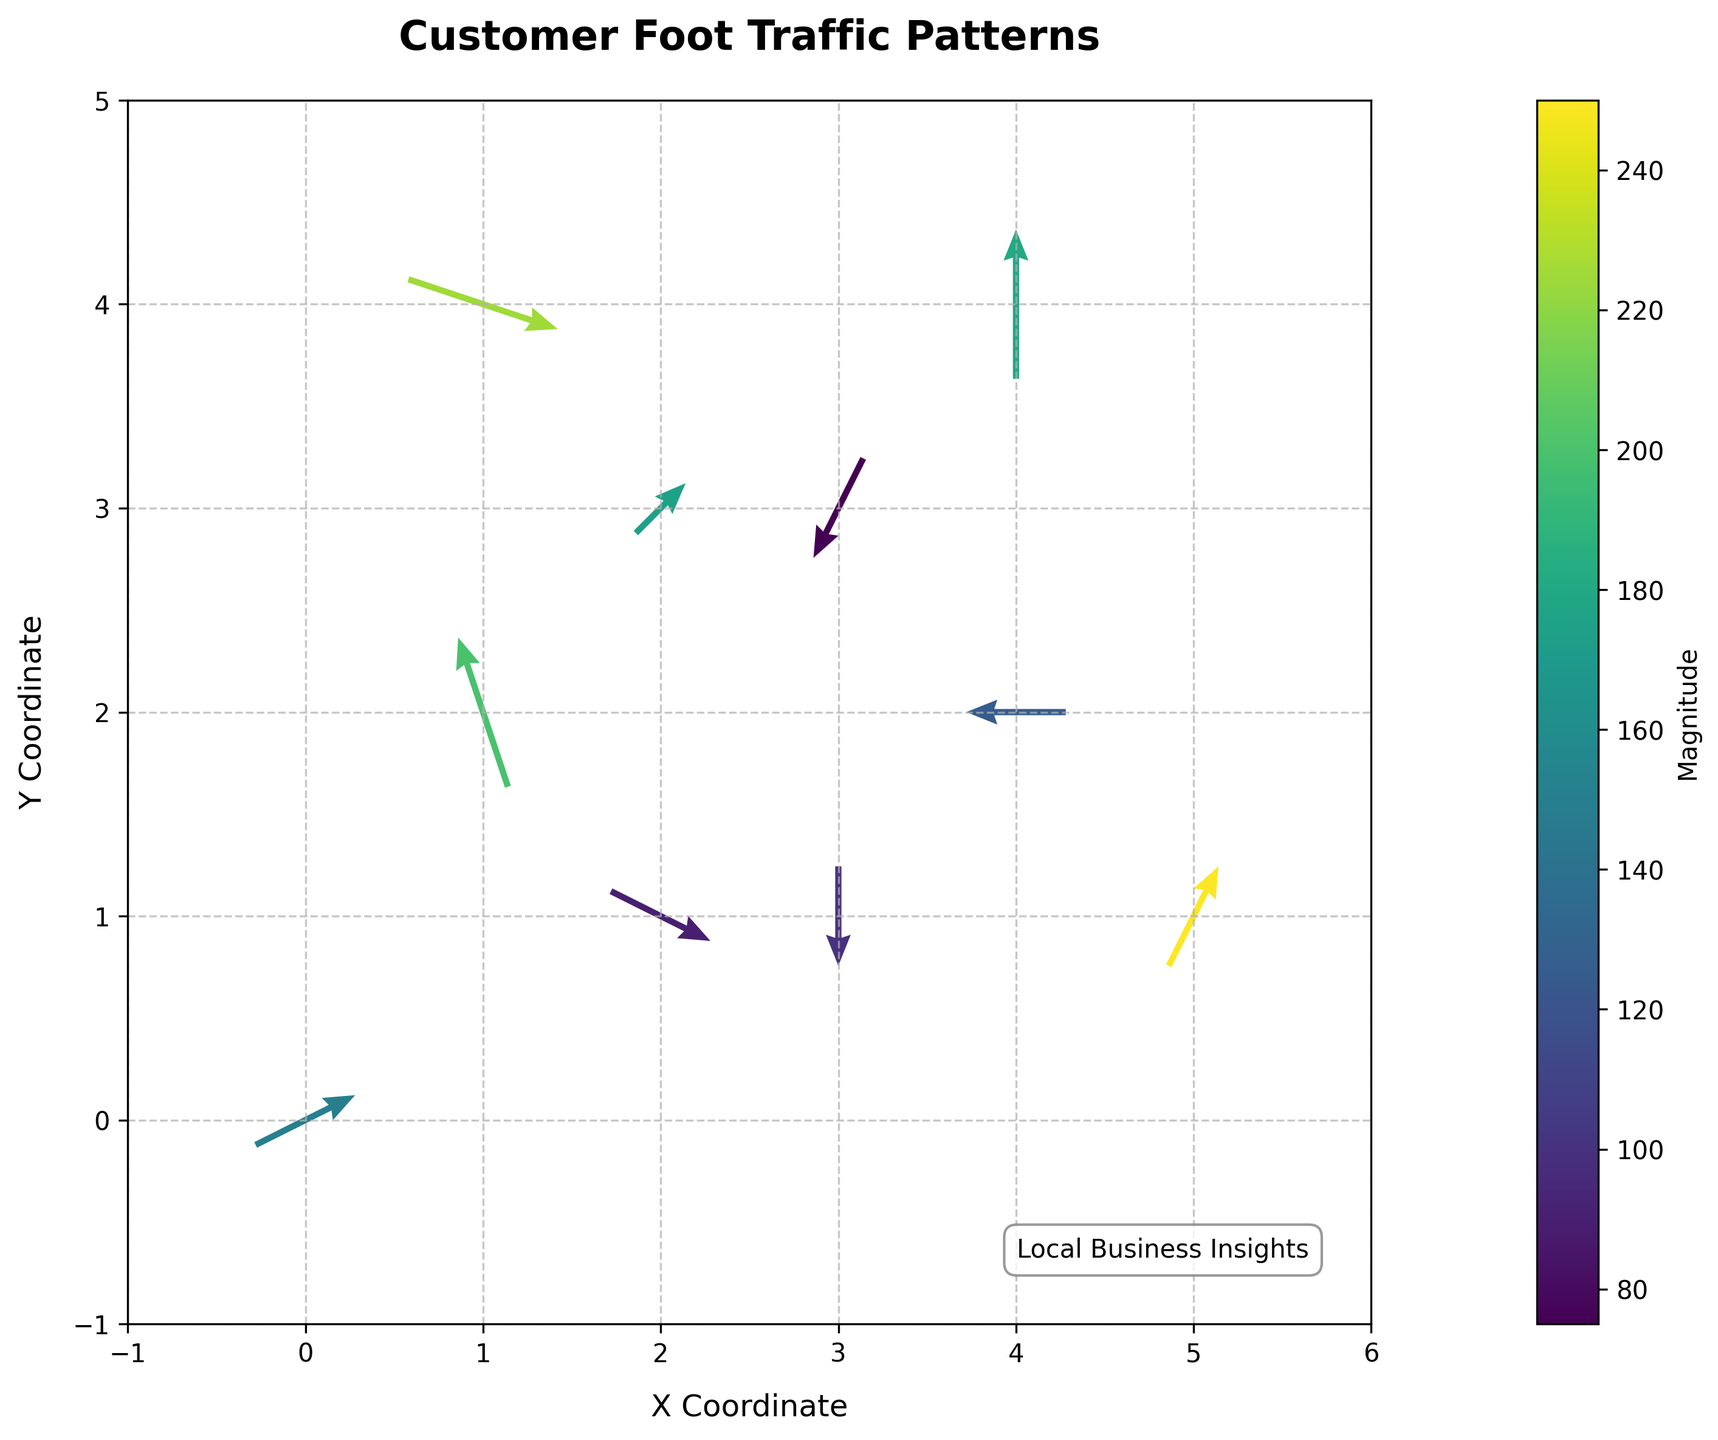What is the title of the figure? The title of the figure is usually located at the top and gives an overall description of the visual data. In this case, it states: "Customer Foot Traffic Patterns"
Answer: Customer Foot Traffic Patterns How many data points are represented in the plot? Each data point is represented by an arrow in the quiver plot. Count the number of arrows to determine the total number of data points. By counting, we see a total of 10 arrows.
Answer: 10 What does the color of the arrows represent? The colors in the quiver plot correspond to the magnitude of the vectors, indicating the intensity of foot traffic. This is further clarified by observing the color bar labeled 'Magnitude' on the side of the plot.
Answer: Magnitude of foot traffic Which arrow has the highest magnitude, and where is it located? To determine the highest magnitude, refer to the color intensity guided by the color bar. The arrow with the brightest or highest color code represents the highest magnitude, which is 250, located at coordinates (5, 1).
Answer: At (5, 1) Which direction does the arrow at (1, 4) point? By identifying the arrow located at coordinates (1, 4), we can observe its direction. This particular arrow points towards the right-down direction (approximately down and to the right).
Answer: Right-down or approximately southeast What is the average magnitude of all data points? To find the average magnitude, sum all the magnitude values and divide by the number of data points. Magnitudes are: 150, 200, 100, 175, 125, 225, 75, 250, 90, 180. Sum these values and divide by 10. (150+200+100+175+125+225+75+250+90+180) = 1570. Average: 1570/10 = 157
Answer: 157 What are the x and y components of the vector with the largest magnitude? The vector with the largest magnitude is 250. Look at the data or the figure to find this vector, which is located at (5, 1) with components u=1 and v=2.
Answer: u = 1, v = 2 Compare the magnitudes at coordinates (4, 2) and (0, 0). Which is larger? Locate both points on the plot. The magnitude at (0, 0) is 150, while the magnitude at (4, 2) is 125. Comparing these values: 150 > 125.
Answer: (0, 0) What is the range of x and y coordinates displayed on the plot? The x-coordinates range from the minimum x to the maximum x value shown, similarly for y-coordinates. Observing the axis scales, the x-coordinates range from -1 to 6 and y-coordinates from -1 to 5.
Answer: x: -1 to 6, y: -1 to 5 